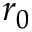<formula> <loc_0><loc_0><loc_500><loc_500>r _ { 0 }</formula> 